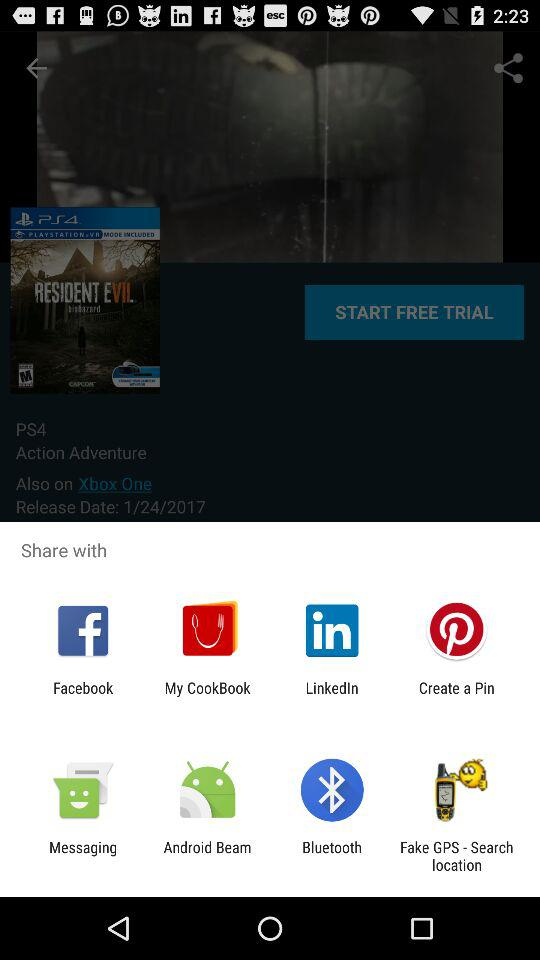What are the different options available for sharing? The different options available for sharing are "Facebook", "My CookBook", "LinkedIn", "Create a Pin", "Messaging", "Android Beam", "Bluetooth" and "Fake GPS - Search location". 